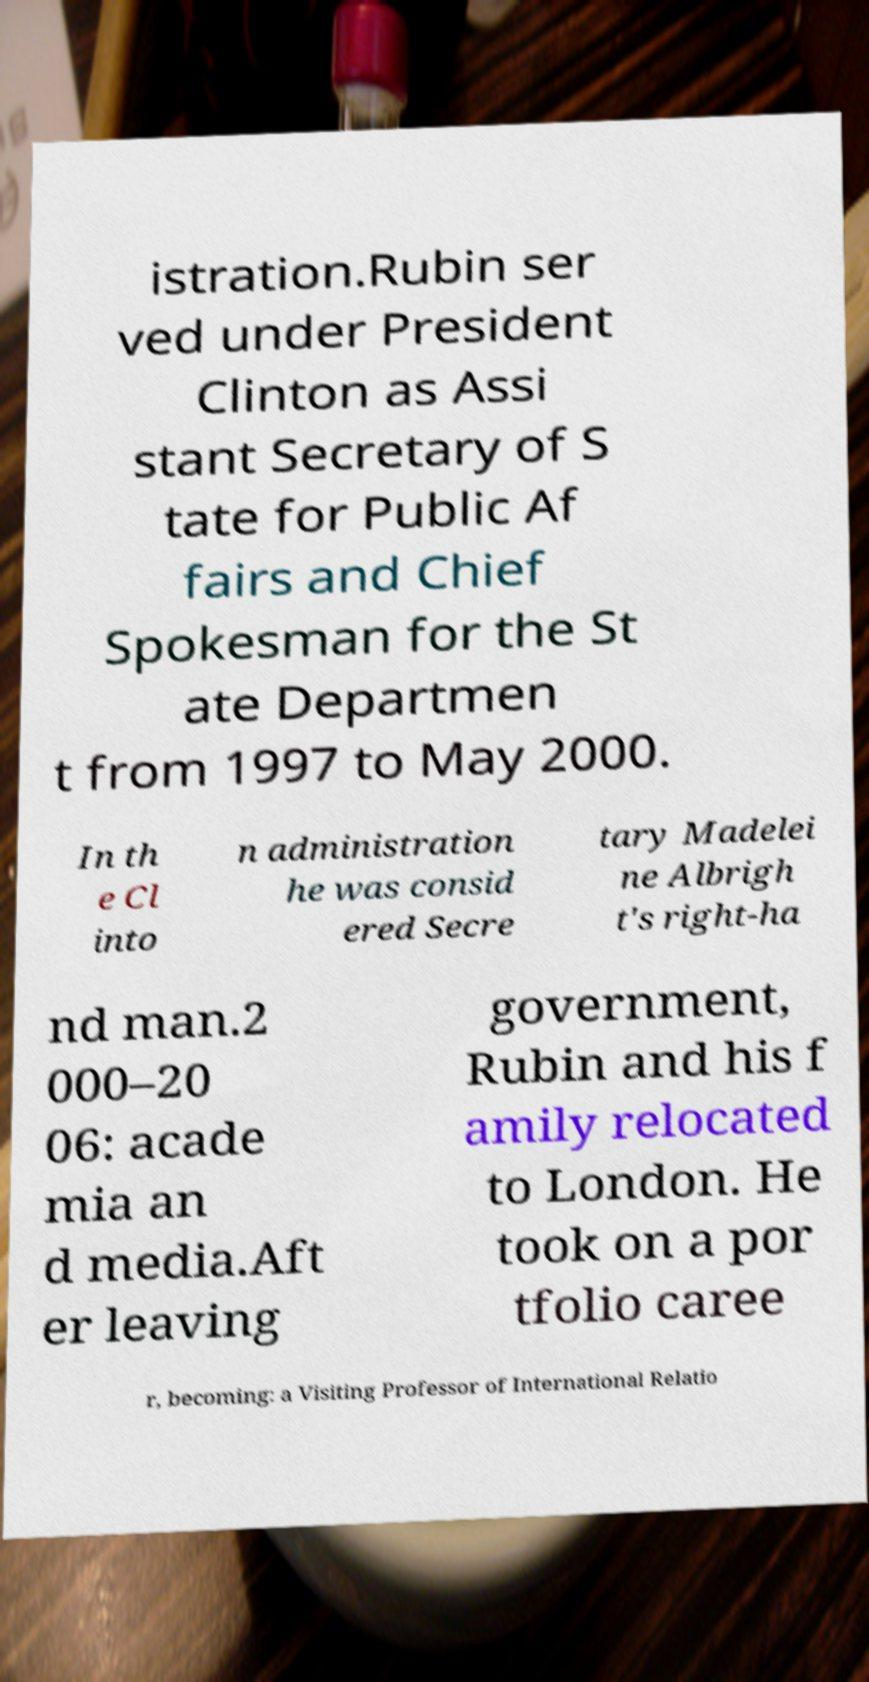Can you accurately transcribe the text from the provided image for me? istration.Rubin ser ved under President Clinton as Assi stant Secretary of S tate for Public Af fairs and Chief Spokesman for the St ate Departmen t from 1997 to May 2000. In th e Cl into n administration he was consid ered Secre tary Madelei ne Albrigh t's right-ha nd man.2 000–20 06: acade mia an d media.Aft er leaving government, Rubin and his f amily relocated to London. He took on a por tfolio caree r, becoming: a Visiting Professor of International Relatio 